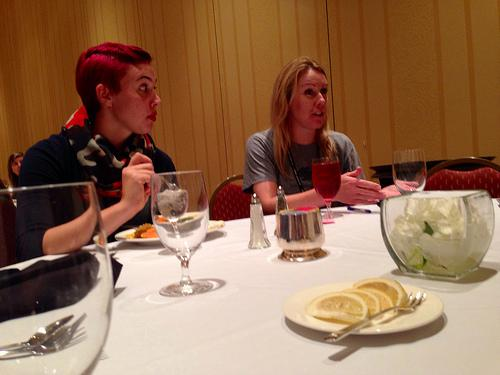Question: what color are the glasses?
Choices:
A. Clear.
B. Red.
C. Green.
D. Black.
Answer with the letter. Answer: A Question: what color are the chairs?
Choices:
A. Black.
B. Blue.
C. Green.
D. Red.
Answer with the letter. Answer: D Question: how many glasses are shown?
Choices:
A. Three.
B. Two.
C. One.
D. Four.
Answer with the letter. Answer: D Question: where are the lemon slices?
Choices:
A. Rim of glass.
B. Plate.
C. Water pitcher.
D. Kitchen.
Answer with the letter. Answer: B 